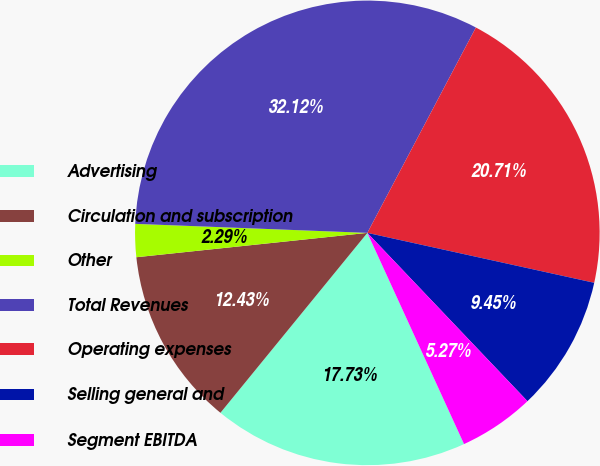Convert chart. <chart><loc_0><loc_0><loc_500><loc_500><pie_chart><fcel>Advertising<fcel>Circulation and subscription<fcel>Other<fcel>Total Revenues<fcel>Operating expenses<fcel>Selling general and<fcel>Segment EBITDA<nl><fcel>17.73%<fcel>12.43%<fcel>2.29%<fcel>32.12%<fcel>20.71%<fcel>9.45%<fcel>5.27%<nl></chart> 